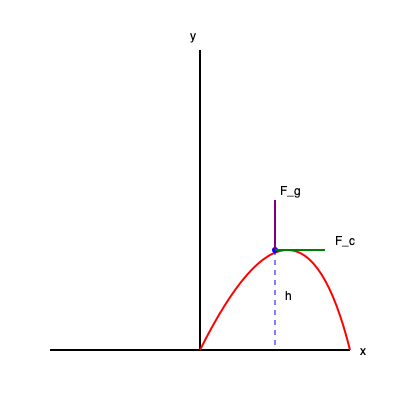During a complex gymnastics move, an athlete performs a backward flip with a twist. At a specific point in the rotation, the athlete's center of mass is at a height $h$ above the ground, moving with a velocity $v$ tangent to the circular path. Given that the athlete's mass is $m$, the radius of curvature at this point is $R$, and the acceleration due to gravity is $g$, calculate the magnitude of the total force acting on the athlete at this instant. To solve this problem, we need to consider two main forces acting on the athlete:

1. Gravitational Force ($F_g$):
   $F_g = mg$, acting vertically downward

2. Centripetal Force ($F_c$):
   $F_c = \frac{mv^2}{R}$, acting perpendicular to the path towards the center of curvature

The total force is the vector sum of these two forces. To find its magnitude, we can use the Pythagorean theorem:

Step 1: Express the forces in terms of given variables
$F_g = mg$
$F_c = \frac{mv^2}{R}$

Step 2: Apply the Pythagorean theorem
$F_{total}^2 = F_g^2 + F_c^2$

Step 3: Substitute the expressions for $F_g$ and $F_c$
$F_{total}^2 = (mg)^2 + (\frac{mv^2}{R})^2$

Step 4: Factor out $m^2$
$F_{total}^2 = m^2(g^2 + \frac{v^4}{R^2})$

Step 5: Take the square root of both sides
$F_{total} = m\sqrt{g^2 + \frac{v^4}{R^2}}$

This expression gives the magnitude of the total force acting on the athlete at the specified instant during the complex gymnastics move.
Answer: $m\sqrt{g^2 + \frac{v^4}{R^2}}$ 